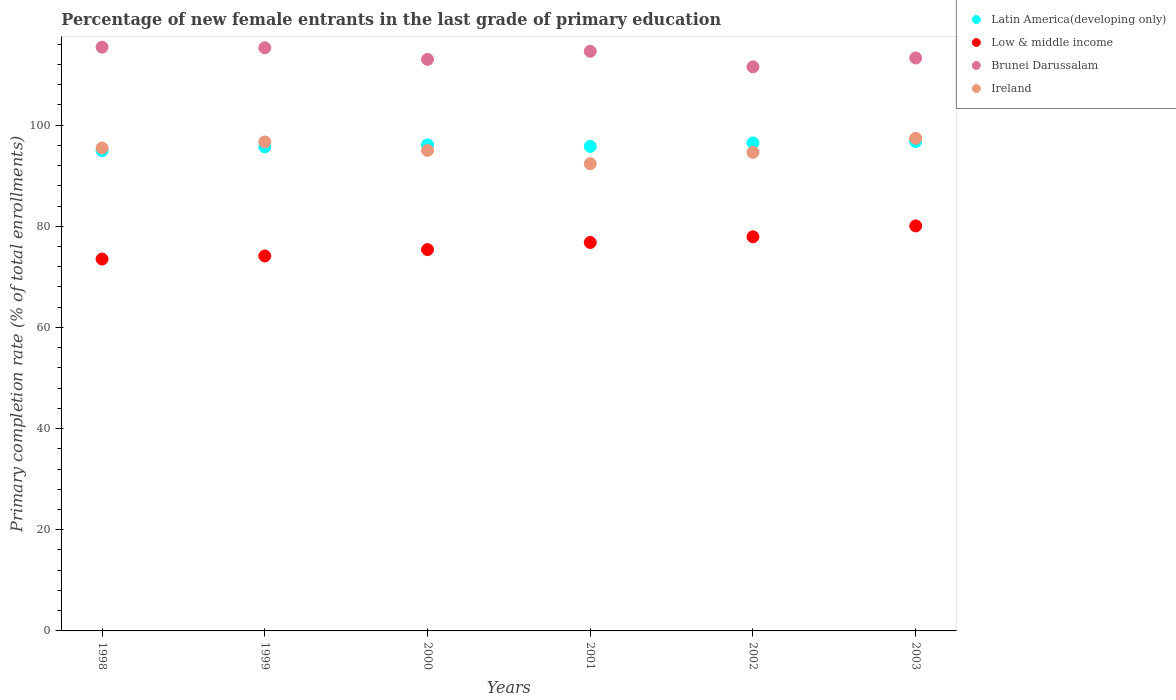How many different coloured dotlines are there?
Give a very brief answer. 4. What is the percentage of new female entrants in Brunei Darussalam in 1999?
Your answer should be compact. 115.28. Across all years, what is the maximum percentage of new female entrants in Ireland?
Provide a short and direct response. 97.38. Across all years, what is the minimum percentage of new female entrants in Low & middle income?
Give a very brief answer. 73.51. In which year was the percentage of new female entrants in Latin America(developing only) maximum?
Give a very brief answer. 2003. What is the total percentage of new female entrants in Low & middle income in the graph?
Give a very brief answer. 457.8. What is the difference between the percentage of new female entrants in Brunei Darussalam in 1999 and that in 2001?
Provide a succinct answer. 0.69. What is the difference between the percentage of new female entrants in Brunei Darussalam in 2002 and the percentage of new female entrants in Latin America(developing only) in 2000?
Offer a terse response. 15.44. What is the average percentage of new female entrants in Latin America(developing only) per year?
Your answer should be compact. 95.95. In the year 2002, what is the difference between the percentage of new female entrants in Brunei Darussalam and percentage of new female entrants in Latin America(developing only)?
Offer a terse response. 15.05. In how many years, is the percentage of new female entrants in Brunei Darussalam greater than 20 %?
Provide a short and direct response. 6. What is the ratio of the percentage of new female entrants in Brunei Darussalam in 2000 to that in 2003?
Your answer should be compact. 1. What is the difference between the highest and the second highest percentage of new female entrants in Latin America(developing only)?
Ensure brevity in your answer.  0.29. What is the difference between the highest and the lowest percentage of new female entrants in Low & middle income?
Provide a short and direct response. 6.55. Is it the case that in every year, the sum of the percentage of new female entrants in Low & middle income and percentage of new female entrants in Latin America(developing only)  is greater than the sum of percentage of new female entrants in Ireland and percentage of new female entrants in Brunei Darussalam?
Your answer should be very brief. No. Does the percentage of new female entrants in Latin America(developing only) monotonically increase over the years?
Your response must be concise. No. Is the percentage of new female entrants in Low & middle income strictly greater than the percentage of new female entrants in Latin America(developing only) over the years?
Your response must be concise. No. How many dotlines are there?
Give a very brief answer. 4. How many years are there in the graph?
Keep it short and to the point. 6. What is the difference between two consecutive major ticks on the Y-axis?
Provide a succinct answer. 20. Are the values on the major ticks of Y-axis written in scientific E-notation?
Your answer should be very brief. No. Does the graph contain grids?
Ensure brevity in your answer.  No. How are the legend labels stacked?
Keep it short and to the point. Vertical. What is the title of the graph?
Your answer should be compact. Percentage of new female entrants in the last grade of primary education. Does "Sao Tome and Principe" appear as one of the legend labels in the graph?
Make the answer very short. No. What is the label or title of the X-axis?
Your response must be concise. Years. What is the label or title of the Y-axis?
Offer a very short reply. Primary completion rate (% of total enrollments). What is the Primary completion rate (% of total enrollments) in Latin America(developing only) in 1998?
Make the answer very short. 94.95. What is the Primary completion rate (% of total enrollments) in Low & middle income in 1998?
Ensure brevity in your answer.  73.51. What is the Primary completion rate (% of total enrollments) in Brunei Darussalam in 1998?
Keep it short and to the point. 115.4. What is the Primary completion rate (% of total enrollments) of Ireland in 1998?
Provide a short and direct response. 95.48. What is the Primary completion rate (% of total enrollments) of Latin America(developing only) in 1999?
Keep it short and to the point. 95.68. What is the Primary completion rate (% of total enrollments) in Low & middle income in 1999?
Offer a very short reply. 74.12. What is the Primary completion rate (% of total enrollments) in Brunei Darussalam in 1999?
Offer a very short reply. 115.28. What is the Primary completion rate (% of total enrollments) of Ireland in 1999?
Provide a succinct answer. 96.67. What is the Primary completion rate (% of total enrollments) of Latin America(developing only) in 2000?
Keep it short and to the point. 96.08. What is the Primary completion rate (% of total enrollments) of Low & middle income in 2000?
Keep it short and to the point. 75.38. What is the Primary completion rate (% of total enrollments) of Brunei Darussalam in 2000?
Offer a very short reply. 112.98. What is the Primary completion rate (% of total enrollments) in Ireland in 2000?
Make the answer very short. 94.98. What is the Primary completion rate (% of total enrollments) in Latin America(developing only) in 2001?
Offer a terse response. 95.79. What is the Primary completion rate (% of total enrollments) in Low & middle income in 2001?
Give a very brief answer. 76.79. What is the Primary completion rate (% of total enrollments) of Brunei Darussalam in 2001?
Make the answer very short. 114.59. What is the Primary completion rate (% of total enrollments) of Ireland in 2001?
Your answer should be very brief. 92.36. What is the Primary completion rate (% of total enrollments) in Latin America(developing only) in 2002?
Provide a succinct answer. 96.47. What is the Primary completion rate (% of total enrollments) of Low & middle income in 2002?
Make the answer very short. 77.92. What is the Primary completion rate (% of total enrollments) of Brunei Darussalam in 2002?
Ensure brevity in your answer.  111.51. What is the Primary completion rate (% of total enrollments) of Ireland in 2002?
Offer a terse response. 94.61. What is the Primary completion rate (% of total enrollments) of Latin America(developing only) in 2003?
Provide a succinct answer. 96.75. What is the Primary completion rate (% of total enrollments) of Low & middle income in 2003?
Provide a succinct answer. 80.07. What is the Primary completion rate (% of total enrollments) of Brunei Darussalam in 2003?
Keep it short and to the point. 113.27. What is the Primary completion rate (% of total enrollments) of Ireland in 2003?
Provide a short and direct response. 97.38. Across all years, what is the maximum Primary completion rate (% of total enrollments) of Latin America(developing only)?
Keep it short and to the point. 96.75. Across all years, what is the maximum Primary completion rate (% of total enrollments) of Low & middle income?
Provide a succinct answer. 80.07. Across all years, what is the maximum Primary completion rate (% of total enrollments) in Brunei Darussalam?
Make the answer very short. 115.4. Across all years, what is the maximum Primary completion rate (% of total enrollments) of Ireland?
Make the answer very short. 97.38. Across all years, what is the minimum Primary completion rate (% of total enrollments) of Latin America(developing only)?
Give a very brief answer. 94.95. Across all years, what is the minimum Primary completion rate (% of total enrollments) in Low & middle income?
Provide a short and direct response. 73.51. Across all years, what is the minimum Primary completion rate (% of total enrollments) in Brunei Darussalam?
Provide a short and direct response. 111.51. Across all years, what is the minimum Primary completion rate (% of total enrollments) of Ireland?
Your response must be concise. 92.36. What is the total Primary completion rate (% of total enrollments) of Latin America(developing only) in the graph?
Give a very brief answer. 575.71. What is the total Primary completion rate (% of total enrollments) of Low & middle income in the graph?
Your answer should be compact. 457.8. What is the total Primary completion rate (% of total enrollments) of Brunei Darussalam in the graph?
Your answer should be very brief. 683.04. What is the total Primary completion rate (% of total enrollments) of Ireland in the graph?
Provide a succinct answer. 571.48. What is the difference between the Primary completion rate (% of total enrollments) of Latin America(developing only) in 1998 and that in 1999?
Provide a short and direct response. -0.74. What is the difference between the Primary completion rate (% of total enrollments) in Low & middle income in 1998 and that in 1999?
Your answer should be compact. -0.61. What is the difference between the Primary completion rate (% of total enrollments) of Brunei Darussalam in 1998 and that in 1999?
Ensure brevity in your answer.  0.12. What is the difference between the Primary completion rate (% of total enrollments) in Ireland in 1998 and that in 1999?
Ensure brevity in your answer.  -1.19. What is the difference between the Primary completion rate (% of total enrollments) of Latin America(developing only) in 1998 and that in 2000?
Provide a succinct answer. -1.13. What is the difference between the Primary completion rate (% of total enrollments) in Low & middle income in 1998 and that in 2000?
Make the answer very short. -1.87. What is the difference between the Primary completion rate (% of total enrollments) in Brunei Darussalam in 1998 and that in 2000?
Your answer should be compact. 2.42. What is the difference between the Primary completion rate (% of total enrollments) in Ireland in 1998 and that in 2000?
Your answer should be compact. 0.49. What is the difference between the Primary completion rate (% of total enrollments) in Latin America(developing only) in 1998 and that in 2001?
Ensure brevity in your answer.  -0.84. What is the difference between the Primary completion rate (% of total enrollments) of Low & middle income in 1998 and that in 2001?
Your answer should be compact. -3.28. What is the difference between the Primary completion rate (% of total enrollments) in Brunei Darussalam in 1998 and that in 2001?
Provide a succinct answer. 0.81. What is the difference between the Primary completion rate (% of total enrollments) of Ireland in 1998 and that in 2001?
Provide a short and direct response. 3.12. What is the difference between the Primary completion rate (% of total enrollments) in Latin America(developing only) in 1998 and that in 2002?
Offer a very short reply. -1.52. What is the difference between the Primary completion rate (% of total enrollments) in Low & middle income in 1998 and that in 2002?
Your response must be concise. -4.4. What is the difference between the Primary completion rate (% of total enrollments) in Brunei Darussalam in 1998 and that in 2002?
Make the answer very short. 3.89. What is the difference between the Primary completion rate (% of total enrollments) in Ireland in 1998 and that in 2002?
Keep it short and to the point. 0.87. What is the difference between the Primary completion rate (% of total enrollments) in Latin America(developing only) in 1998 and that in 2003?
Ensure brevity in your answer.  -1.81. What is the difference between the Primary completion rate (% of total enrollments) in Low & middle income in 1998 and that in 2003?
Ensure brevity in your answer.  -6.55. What is the difference between the Primary completion rate (% of total enrollments) of Brunei Darussalam in 1998 and that in 2003?
Offer a terse response. 2.13. What is the difference between the Primary completion rate (% of total enrollments) of Ireland in 1998 and that in 2003?
Make the answer very short. -1.9. What is the difference between the Primary completion rate (% of total enrollments) in Latin America(developing only) in 1999 and that in 2000?
Offer a terse response. -0.39. What is the difference between the Primary completion rate (% of total enrollments) of Low & middle income in 1999 and that in 2000?
Ensure brevity in your answer.  -1.26. What is the difference between the Primary completion rate (% of total enrollments) in Brunei Darussalam in 1999 and that in 2000?
Your response must be concise. 2.3. What is the difference between the Primary completion rate (% of total enrollments) in Ireland in 1999 and that in 2000?
Your response must be concise. 1.68. What is the difference between the Primary completion rate (% of total enrollments) in Latin America(developing only) in 1999 and that in 2001?
Provide a succinct answer. -0.1. What is the difference between the Primary completion rate (% of total enrollments) of Low & middle income in 1999 and that in 2001?
Your response must be concise. -2.67. What is the difference between the Primary completion rate (% of total enrollments) of Brunei Darussalam in 1999 and that in 2001?
Your response must be concise. 0.69. What is the difference between the Primary completion rate (% of total enrollments) in Ireland in 1999 and that in 2001?
Keep it short and to the point. 4.31. What is the difference between the Primary completion rate (% of total enrollments) of Latin America(developing only) in 1999 and that in 2002?
Give a very brief answer. -0.78. What is the difference between the Primary completion rate (% of total enrollments) in Low & middle income in 1999 and that in 2002?
Provide a succinct answer. -3.79. What is the difference between the Primary completion rate (% of total enrollments) of Brunei Darussalam in 1999 and that in 2002?
Offer a terse response. 3.77. What is the difference between the Primary completion rate (% of total enrollments) of Ireland in 1999 and that in 2002?
Keep it short and to the point. 2.06. What is the difference between the Primary completion rate (% of total enrollments) of Latin America(developing only) in 1999 and that in 2003?
Your answer should be compact. -1.07. What is the difference between the Primary completion rate (% of total enrollments) in Low & middle income in 1999 and that in 2003?
Your answer should be compact. -5.94. What is the difference between the Primary completion rate (% of total enrollments) of Brunei Darussalam in 1999 and that in 2003?
Your answer should be very brief. 2.01. What is the difference between the Primary completion rate (% of total enrollments) in Ireland in 1999 and that in 2003?
Offer a very short reply. -0.72. What is the difference between the Primary completion rate (% of total enrollments) of Latin America(developing only) in 2000 and that in 2001?
Provide a short and direct response. 0.29. What is the difference between the Primary completion rate (% of total enrollments) in Low & middle income in 2000 and that in 2001?
Offer a very short reply. -1.41. What is the difference between the Primary completion rate (% of total enrollments) of Brunei Darussalam in 2000 and that in 2001?
Your answer should be very brief. -1.61. What is the difference between the Primary completion rate (% of total enrollments) in Ireland in 2000 and that in 2001?
Offer a terse response. 2.63. What is the difference between the Primary completion rate (% of total enrollments) in Latin America(developing only) in 2000 and that in 2002?
Offer a terse response. -0.39. What is the difference between the Primary completion rate (% of total enrollments) in Low & middle income in 2000 and that in 2002?
Keep it short and to the point. -2.53. What is the difference between the Primary completion rate (% of total enrollments) of Brunei Darussalam in 2000 and that in 2002?
Keep it short and to the point. 1.47. What is the difference between the Primary completion rate (% of total enrollments) of Ireland in 2000 and that in 2002?
Offer a terse response. 0.37. What is the difference between the Primary completion rate (% of total enrollments) in Latin America(developing only) in 2000 and that in 2003?
Provide a short and direct response. -0.68. What is the difference between the Primary completion rate (% of total enrollments) in Low & middle income in 2000 and that in 2003?
Give a very brief answer. -4.68. What is the difference between the Primary completion rate (% of total enrollments) in Brunei Darussalam in 2000 and that in 2003?
Give a very brief answer. -0.28. What is the difference between the Primary completion rate (% of total enrollments) in Ireland in 2000 and that in 2003?
Make the answer very short. -2.4. What is the difference between the Primary completion rate (% of total enrollments) of Latin America(developing only) in 2001 and that in 2002?
Offer a very short reply. -0.68. What is the difference between the Primary completion rate (% of total enrollments) in Low & middle income in 2001 and that in 2002?
Your answer should be very brief. -1.12. What is the difference between the Primary completion rate (% of total enrollments) in Brunei Darussalam in 2001 and that in 2002?
Provide a short and direct response. 3.08. What is the difference between the Primary completion rate (% of total enrollments) in Ireland in 2001 and that in 2002?
Ensure brevity in your answer.  -2.25. What is the difference between the Primary completion rate (% of total enrollments) of Latin America(developing only) in 2001 and that in 2003?
Offer a very short reply. -0.96. What is the difference between the Primary completion rate (% of total enrollments) in Low & middle income in 2001 and that in 2003?
Offer a terse response. -3.27. What is the difference between the Primary completion rate (% of total enrollments) of Brunei Darussalam in 2001 and that in 2003?
Your answer should be compact. 1.32. What is the difference between the Primary completion rate (% of total enrollments) in Ireland in 2001 and that in 2003?
Your response must be concise. -5.03. What is the difference between the Primary completion rate (% of total enrollments) in Latin America(developing only) in 2002 and that in 2003?
Offer a very short reply. -0.29. What is the difference between the Primary completion rate (% of total enrollments) in Low & middle income in 2002 and that in 2003?
Your answer should be very brief. -2.15. What is the difference between the Primary completion rate (% of total enrollments) in Brunei Darussalam in 2002 and that in 2003?
Your answer should be very brief. -1.76. What is the difference between the Primary completion rate (% of total enrollments) of Ireland in 2002 and that in 2003?
Ensure brevity in your answer.  -2.77. What is the difference between the Primary completion rate (% of total enrollments) in Latin America(developing only) in 1998 and the Primary completion rate (% of total enrollments) in Low & middle income in 1999?
Provide a succinct answer. 20.82. What is the difference between the Primary completion rate (% of total enrollments) in Latin America(developing only) in 1998 and the Primary completion rate (% of total enrollments) in Brunei Darussalam in 1999?
Make the answer very short. -20.33. What is the difference between the Primary completion rate (% of total enrollments) of Latin America(developing only) in 1998 and the Primary completion rate (% of total enrollments) of Ireland in 1999?
Keep it short and to the point. -1.72. What is the difference between the Primary completion rate (% of total enrollments) of Low & middle income in 1998 and the Primary completion rate (% of total enrollments) of Brunei Darussalam in 1999?
Offer a very short reply. -41.77. What is the difference between the Primary completion rate (% of total enrollments) of Low & middle income in 1998 and the Primary completion rate (% of total enrollments) of Ireland in 1999?
Offer a terse response. -23.16. What is the difference between the Primary completion rate (% of total enrollments) of Brunei Darussalam in 1998 and the Primary completion rate (% of total enrollments) of Ireland in 1999?
Make the answer very short. 18.73. What is the difference between the Primary completion rate (% of total enrollments) of Latin America(developing only) in 1998 and the Primary completion rate (% of total enrollments) of Low & middle income in 2000?
Your answer should be very brief. 19.56. What is the difference between the Primary completion rate (% of total enrollments) in Latin America(developing only) in 1998 and the Primary completion rate (% of total enrollments) in Brunei Darussalam in 2000?
Your response must be concise. -18.04. What is the difference between the Primary completion rate (% of total enrollments) of Latin America(developing only) in 1998 and the Primary completion rate (% of total enrollments) of Ireland in 2000?
Your response must be concise. -0.04. What is the difference between the Primary completion rate (% of total enrollments) of Low & middle income in 1998 and the Primary completion rate (% of total enrollments) of Brunei Darussalam in 2000?
Ensure brevity in your answer.  -39.47. What is the difference between the Primary completion rate (% of total enrollments) in Low & middle income in 1998 and the Primary completion rate (% of total enrollments) in Ireland in 2000?
Make the answer very short. -21.47. What is the difference between the Primary completion rate (% of total enrollments) of Brunei Darussalam in 1998 and the Primary completion rate (% of total enrollments) of Ireland in 2000?
Your response must be concise. 20.42. What is the difference between the Primary completion rate (% of total enrollments) in Latin America(developing only) in 1998 and the Primary completion rate (% of total enrollments) in Low & middle income in 2001?
Give a very brief answer. 18.15. What is the difference between the Primary completion rate (% of total enrollments) in Latin America(developing only) in 1998 and the Primary completion rate (% of total enrollments) in Brunei Darussalam in 2001?
Ensure brevity in your answer.  -19.64. What is the difference between the Primary completion rate (% of total enrollments) in Latin America(developing only) in 1998 and the Primary completion rate (% of total enrollments) in Ireland in 2001?
Give a very brief answer. 2.59. What is the difference between the Primary completion rate (% of total enrollments) of Low & middle income in 1998 and the Primary completion rate (% of total enrollments) of Brunei Darussalam in 2001?
Your response must be concise. -41.08. What is the difference between the Primary completion rate (% of total enrollments) of Low & middle income in 1998 and the Primary completion rate (% of total enrollments) of Ireland in 2001?
Offer a terse response. -18.84. What is the difference between the Primary completion rate (% of total enrollments) of Brunei Darussalam in 1998 and the Primary completion rate (% of total enrollments) of Ireland in 2001?
Provide a succinct answer. 23.05. What is the difference between the Primary completion rate (% of total enrollments) of Latin America(developing only) in 1998 and the Primary completion rate (% of total enrollments) of Low & middle income in 2002?
Keep it short and to the point. 17.03. What is the difference between the Primary completion rate (% of total enrollments) in Latin America(developing only) in 1998 and the Primary completion rate (% of total enrollments) in Brunei Darussalam in 2002?
Provide a succinct answer. -16.57. What is the difference between the Primary completion rate (% of total enrollments) of Latin America(developing only) in 1998 and the Primary completion rate (% of total enrollments) of Ireland in 2002?
Offer a terse response. 0.34. What is the difference between the Primary completion rate (% of total enrollments) of Low & middle income in 1998 and the Primary completion rate (% of total enrollments) of Brunei Darussalam in 2002?
Keep it short and to the point. -38. What is the difference between the Primary completion rate (% of total enrollments) of Low & middle income in 1998 and the Primary completion rate (% of total enrollments) of Ireland in 2002?
Give a very brief answer. -21.1. What is the difference between the Primary completion rate (% of total enrollments) in Brunei Darussalam in 1998 and the Primary completion rate (% of total enrollments) in Ireland in 2002?
Ensure brevity in your answer.  20.79. What is the difference between the Primary completion rate (% of total enrollments) of Latin America(developing only) in 1998 and the Primary completion rate (% of total enrollments) of Low & middle income in 2003?
Your response must be concise. 14.88. What is the difference between the Primary completion rate (% of total enrollments) in Latin America(developing only) in 1998 and the Primary completion rate (% of total enrollments) in Brunei Darussalam in 2003?
Provide a succinct answer. -18.32. What is the difference between the Primary completion rate (% of total enrollments) in Latin America(developing only) in 1998 and the Primary completion rate (% of total enrollments) in Ireland in 2003?
Make the answer very short. -2.44. What is the difference between the Primary completion rate (% of total enrollments) in Low & middle income in 1998 and the Primary completion rate (% of total enrollments) in Brunei Darussalam in 2003?
Your answer should be compact. -39.76. What is the difference between the Primary completion rate (% of total enrollments) of Low & middle income in 1998 and the Primary completion rate (% of total enrollments) of Ireland in 2003?
Your response must be concise. -23.87. What is the difference between the Primary completion rate (% of total enrollments) of Brunei Darussalam in 1998 and the Primary completion rate (% of total enrollments) of Ireland in 2003?
Offer a terse response. 18.02. What is the difference between the Primary completion rate (% of total enrollments) of Latin America(developing only) in 1999 and the Primary completion rate (% of total enrollments) of Low & middle income in 2000?
Make the answer very short. 20.3. What is the difference between the Primary completion rate (% of total enrollments) of Latin America(developing only) in 1999 and the Primary completion rate (% of total enrollments) of Brunei Darussalam in 2000?
Your response must be concise. -17.3. What is the difference between the Primary completion rate (% of total enrollments) in Latin America(developing only) in 1999 and the Primary completion rate (% of total enrollments) in Ireland in 2000?
Offer a terse response. 0.7. What is the difference between the Primary completion rate (% of total enrollments) of Low & middle income in 1999 and the Primary completion rate (% of total enrollments) of Brunei Darussalam in 2000?
Provide a short and direct response. -38.86. What is the difference between the Primary completion rate (% of total enrollments) in Low & middle income in 1999 and the Primary completion rate (% of total enrollments) in Ireland in 2000?
Offer a terse response. -20.86. What is the difference between the Primary completion rate (% of total enrollments) in Brunei Darussalam in 1999 and the Primary completion rate (% of total enrollments) in Ireland in 2000?
Keep it short and to the point. 20.3. What is the difference between the Primary completion rate (% of total enrollments) of Latin America(developing only) in 1999 and the Primary completion rate (% of total enrollments) of Low & middle income in 2001?
Give a very brief answer. 18.89. What is the difference between the Primary completion rate (% of total enrollments) of Latin America(developing only) in 1999 and the Primary completion rate (% of total enrollments) of Brunei Darussalam in 2001?
Provide a short and direct response. -18.91. What is the difference between the Primary completion rate (% of total enrollments) of Latin America(developing only) in 1999 and the Primary completion rate (% of total enrollments) of Ireland in 2001?
Your answer should be compact. 3.33. What is the difference between the Primary completion rate (% of total enrollments) in Low & middle income in 1999 and the Primary completion rate (% of total enrollments) in Brunei Darussalam in 2001?
Provide a succinct answer. -40.47. What is the difference between the Primary completion rate (% of total enrollments) of Low & middle income in 1999 and the Primary completion rate (% of total enrollments) of Ireland in 2001?
Your answer should be very brief. -18.23. What is the difference between the Primary completion rate (% of total enrollments) in Brunei Darussalam in 1999 and the Primary completion rate (% of total enrollments) in Ireland in 2001?
Keep it short and to the point. 22.92. What is the difference between the Primary completion rate (% of total enrollments) in Latin America(developing only) in 1999 and the Primary completion rate (% of total enrollments) in Low & middle income in 2002?
Your answer should be very brief. 17.77. What is the difference between the Primary completion rate (% of total enrollments) in Latin America(developing only) in 1999 and the Primary completion rate (% of total enrollments) in Brunei Darussalam in 2002?
Provide a succinct answer. -15.83. What is the difference between the Primary completion rate (% of total enrollments) in Latin America(developing only) in 1999 and the Primary completion rate (% of total enrollments) in Ireland in 2002?
Give a very brief answer. 1.07. What is the difference between the Primary completion rate (% of total enrollments) in Low & middle income in 1999 and the Primary completion rate (% of total enrollments) in Brunei Darussalam in 2002?
Your answer should be compact. -37.39. What is the difference between the Primary completion rate (% of total enrollments) of Low & middle income in 1999 and the Primary completion rate (% of total enrollments) of Ireland in 2002?
Ensure brevity in your answer.  -20.49. What is the difference between the Primary completion rate (% of total enrollments) in Brunei Darussalam in 1999 and the Primary completion rate (% of total enrollments) in Ireland in 2002?
Provide a succinct answer. 20.67. What is the difference between the Primary completion rate (% of total enrollments) of Latin America(developing only) in 1999 and the Primary completion rate (% of total enrollments) of Low & middle income in 2003?
Your answer should be compact. 15.62. What is the difference between the Primary completion rate (% of total enrollments) of Latin America(developing only) in 1999 and the Primary completion rate (% of total enrollments) of Brunei Darussalam in 2003?
Your response must be concise. -17.58. What is the difference between the Primary completion rate (% of total enrollments) in Latin America(developing only) in 1999 and the Primary completion rate (% of total enrollments) in Ireland in 2003?
Make the answer very short. -1.7. What is the difference between the Primary completion rate (% of total enrollments) in Low & middle income in 1999 and the Primary completion rate (% of total enrollments) in Brunei Darussalam in 2003?
Provide a short and direct response. -39.14. What is the difference between the Primary completion rate (% of total enrollments) in Low & middle income in 1999 and the Primary completion rate (% of total enrollments) in Ireland in 2003?
Offer a terse response. -23.26. What is the difference between the Primary completion rate (% of total enrollments) in Brunei Darussalam in 1999 and the Primary completion rate (% of total enrollments) in Ireland in 2003?
Give a very brief answer. 17.9. What is the difference between the Primary completion rate (% of total enrollments) of Latin America(developing only) in 2000 and the Primary completion rate (% of total enrollments) of Low & middle income in 2001?
Make the answer very short. 19.28. What is the difference between the Primary completion rate (% of total enrollments) in Latin America(developing only) in 2000 and the Primary completion rate (% of total enrollments) in Brunei Darussalam in 2001?
Give a very brief answer. -18.51. What is the difference between the Primary completion rate (% of total enrollments) in Latin America(developing only) in 2000 and the Primary completion rate (% of total enrollments) in Ireland in 2001?
Your answer should be compact. 3.72. What is the difference between the Primary completion rate (% of total enrollments) of Low & middle income in 2000 and the Primary completion rate (% of total enrollments) of Brunei Darussalam in 2001?
Offer a very short reply. -39.21. What is the difference between the Primary completion rate (% of total enrollments) of Low & middle income in 2000 and the Primary completion rate (% of total enrollments) of Ireland in 2001?
Give a very brief answer. -16.97. What is the difference between the Primary completion rate (% of total enrollments) of Brunei Darussalam in 2000 and the Primary completion rate (% of total enrollments) of Ireland in 2001?
Ensure brevity in your answer.  20.63. What is the difference between the Primary completion rate (% of total enrollments) in Latin America(developing only) in 2000 and the Primary completion rate (% of total enrollments) in Low & middle income in 2002?
Keep it short and to the point. 18.16. What is the difference between the Primary completion rate (% of total enrollments) of Latin America(developing only) in 2000 and the Primary completion rate (% of total enrollments) of Brunei Darussalam in 2002?
Your answer should be compact. -15.44. What is the difference between the Primary completion rate (% of total enrollments) of Latin America(developing only) in 2000 and the Primary completion rate (% of total enrollments) of Ireland in 2002?
Ensure brevity in your answer.  1.46. What is the difference between the Primary completion rate (% of total enrollments) of Low & middle income in 2000 and the Primary completion rate (% of total enrollments) of Brunei Darussalam in 2002?
Ensure brevity in your answer.  -36.13. What is the difference between the Primary completion rate (% of total enrollments) in Low & middle income in 2000 and the Primary completion rate (% of total enrollments) in Ireland in 2002?
Your response must be concise. -19.23. What is the difference between the Primary completion rate (% of total enrollments) of Brunei Darussalam in 2000 and the Primary completion rate (% of total enrollments) of Ireland in 2002?
Keep it short and to the point. 18.37. What is the difference between the Primary completion rate (% of total enrollments) of Latin America(developing only) in 2000 and the Primary completion rate (% of total enrollments) of Low & middle income in 2003?
Give a very brief answer. 16.01. What is the difference between the Primary completion rate (% of total enrollments) of Latin America(developing only) in 2000 and the Primary completion rate (% of total enrollments) of Brunei Darussalam in 2003?
Offer a very short reply. -17.19. What is the difference between the Primary completion rate (% of total enrollments) in Latin America(developing only) in 2000 and the Primary completion rate (% of total enrollments) in Ireland in 2003?
Offer a terse response. -1.31. What is the difference between the Primary completion rate (% of total enrollments) of Low & middle income in 2000 and the Primary completion rate (% of total enrollments) of Brunei Darussalam in 2003?
Provide a short and direct response. -37.89. What is the difference between the Primary completion rate (% of total enrollments) in Low & middle income in 2000 and the Primary completion rate (% of total enrollments) in Ireland in 2003?
Make the answer very short. -22. What is the difference between the Primary completion rate (% of total enrollments) in Brunei Darussalam in 2000 and the Primary completion rate (% of total enrollments) in Ireland in 2003?
Your answer should be very brief. 15.6. What is the difference between the Primary completion rate (% of total enrollments) in Latin America(developing only) in 2001 and the Primary completion rate (% of total enrollments) in Low & middle income in 2002?
Ensure brevity in your answer.  17.87. What is the difference between the Primary completion rate (% of total enrollments) of Latin America(developing only) in 2001 and the Primary completion rate (% of total enrollments) of Brunei Darussalam in 2002?
Your answer should be compact. -15.72. What is the difference between the Primary completion rate (% of total enrollments) of Latin America(developing only) in 2001 and the Primary completion rate (% of total enrollments) of Ireland in 2002?
Your response must be concise. 1.18. What is the difference between the Primary completion rate (% of total enrollments) of Low & middle income in 2001 and the Primary completion rate (% of total enrollments) of Brunei Darussalam in 2002?
Your answer should be very brief. -34.72. What is the difference between the Primary completion rate (% of total enrollments) of Low & middle income in 2001 and the Primary completion rate (% of total enrollments) of Ireland in 2002?
Provide a short and direct response. -17.82. What is the difference between the Primary completion rate (% of total enrollments) of Brunei Darussalam in 2001 and the Primary completion rate (% of total enrollments) of Ireland in 2002?
Your answer should be very brief. 19.98. What is the difference between the Primary completion rate (% of total enrollments) of Latin America(developing only) in 2001 and the Primary completion rate (% of total enrollments) of Low & middle income in 2003?
Your answer should be very brief. 15.72. What is the difference between the Primary completion rate (% of total enrollments) of Latin America(developing only) in 2001 and the Primary completion rate (% of total enrollments) of Brunei Darussalam in 2003?
Give a very brief answer. -17.48. What is the difference between the Primary completion rate (% of total enrollments) in Latin America(developing only) in 2001 and the Primary completion rate (% of total enrollments) in Ireland in 2003?
Your answer should be very brief. -1.59. What is the difference between the Primary completion rate (% of total enrollments) in Low & middle income in 2001 and the Primary completion rate (% of total enrollments) in Brunei Darussalam in 2003?
Your answer should be very brief. -36.48. What is the difference between the Primary completion rate (% of total enrollments) in Low & middle income in 2001 and the Primary completion rate (% of total enrollments) in Ireland in 2003?
Ensure brevity in your answer.  -20.59. What is the difference between the Primary completion rate (% of total enrollments) of Brunei Darussalam in 2001 and the Primary completion rate (% of total enrollments) of Ireland in 2003?
Your answer should be compact. 17.21. What is the difference between the Primary completion rate (% of total enrollments) in Latin America(developing only) in 2002 and the Primary completion rate (% of total enrollments) in Low & middle income in 2003?
Offer a terse response. 16.4. What is the difference between the Primary completion rate (% of total enrollments) in Latin America(developing only) in 2002 and the Primary completion rate (% of total enrollments) in Brunei Darussalam in 2003?
Keep it short and to the point. -16.8. What is the difference between the Primary completion rate (% of total enrollments) of Latin America(developing only) in 2002 and the Primary completion rate (% of total enrollments) of Ireland in 2003?
Provide a succinct answer. -0.92. What is the difference between the Primary completion rate (% of total enrollments) in Low & middle income in 2002 and the Primary completion rate (% of total enrollments) in Brunei Darussalam in 2003?
Give a very brief answer. -35.35. What is the difference between the Primary completion rate (% of total enrollments) of Low & middle income in 2002 and the Primary completion rate (% of total enrollments) of Ireland in 2003?
Offer a very short reply. -19.47. What is the difference between the Primary completion rate (% of total enrollments) of Brunei Darussalam in 2002 and the Primary completion rate (% of total enrollments) of Ireland in 2003?
Make the answer very short. 14.13. What is the average Primary completion rate (% of total enrollments) of Latin America(developing only) per year?
Your answer should be compact. 95.95. What is the average Primary completion rate (% of total enrollments) in Low & middle income per year?
Your answer should be very brief. 76.3. What is the average Primary completion rate (% of total enrollments) of Brunei Darussalam per year?
Provide a succinct answer. 113.84. What is the average Primary completion rate (% of total enrollments) in Ireland per year?
Your response must be concise. 95.25. In the year 1998, what is the difference between the Primary completion rate (% of total enrollments) of Latin America(developing only) and Primary completion rate (% of total enrollments) of Low & middle income?
Provide a short and direct response. 21.43. In the year 1998, what is the difference between the Primary completion rate (% of total enrollments) in Latin America(developing only) and Primary completion rate (% of total enrollments) in Brunei Darussalam?
Ensure brevity in your answer.  -20.46. In the year 1998, what is the difference between the Primary completion rate (% of total enrollments) of Latin America(developing only) and Primary completion rate (% of total enrollments) of Ireland?
Ensure brevity in your answer.  -0.53. In the year 1998, what is the difference between the Primary completion rate (% of total enrollments) of Low & middle income and Primary completion rate (% of total enrollments) of Brunei Darussalam?
Offer a terse response. -41.89. In the year 1998, what is the difference between the Primary completion rate (% of total enrollments) in Low & middle income and Primary completion rate (% of total enrollments) in Ireland?
Make the answer very short. -21.97. In the year 1998, what is the difference between the Primary completion rate (% of total enrollments) of Brunei Darussalam and Primary completion rate (% of total enrollments) of Ireland?
Your answer should be very brief. 19.92. In the year 1999, what is the difference between the Primary completion rate (% of total enrollments) in Latin America(developing only) and Primary completion rate (% of total enrollments) in Low & middle income?
Offer a terse response. 21.56. In the year 1999, what is the difference between the Primary completion rate (% of total enrollments) of Latin America(developing only) and Primary completion rate (% of total enrollments) of Brunei Darussalam?
Your answer should be very brief. -19.6. In the year 1999, what is the difference between the Primary completion rate (% of total enrollments) in Latin America(developing only) and Primary completion rate (% of total enrollments) in Ireland?
Offer a terse response. -0.98. In the year 1999, what is the difference between the Primary completion rate (% of total enrollments) of Low & middle income and Primary completion rate (% of total enrollments) of Brunei Darussalam?
Offer a very short reply. -41.16. In the year 1999, what is the difference between the Primary completion rate (% of total enrollments) in Low & middle income and Primary completion rate (% of total enrollments) in Ireland?
Your answer should be very brief. -22.54. In the year 1999, what is the difference between the Primary completion rate (% of total enrollments) of Brunei Darussalam and Primary completion rate (% of total enrollments) of Ireland?
Make the answer very short. 18.61. In the year 2000, what is the difference between the Primary completion rate (% of total enrollments) in Latin America(developing only) and Primary completion rate (% of total enrollments) in Low & middle income?
Provide a short and direct response. 20.69. In the year 2000, what is the difference between the Primary completion rate (% of total enrollments) of Latin America(developing only) and Primary completion rate (% of total enrollments) of Brunei Darussalam?
Give a very brief answer. -16.91. In the year 2000, what is the difference between the Primary completion rate (% of total enrollments) of Latin America(developing only) and Primary completion rate (% of total enrollments) of Ireland?
Your answer should be compact. 1.09. In the year 2000, what is the difference between the Primary completion rate (% of total enrollments) of Low & middle income and Primary completion rate (% of total enrollments) of Brunei Darussalam?
Offer a terse response. -37.6. In the year 2000, what is the difference between the Primary completion rate (% of total enrollments) in Low & middle income and Primary completion rate (% of total enrollments) in Ireland?
Give a very brief answer. -19.6. In the year 2000, what is the difference between the Primary completion rate (% of total enrollments) of Brunei Darussalam and Primary completion rate (% of total enrollments) of Ireland?
Give a very brief answer. 18. In the year 2001, what is the difference between the Primary completion rate (% of total enrollments) in Latin America(developing only) and Primary completion rate (% of total enrollments) in Low & middle income?
Your response must be concise. 19. In the year 2001, what is the difference between the Primary completion rate (% of total enrollments) in Latin America(developing only) and Primary completion rate (% of total enrollments) in Brunei Darussalam?
Your answer should be compact. -18.8. In the year 2001, what is the difference between the Primary completion rate (% of total enrollments) of Latin America(developing only) and Primary completion rate (% of total enrollments) of Ireland?
Keep it short and to the point. 3.43. In the year 2001, what is the difference between the Primary completion rate (% of total enrollments) in Low & middle income and Primary completion rate (% of total enrollments) in Brunei Darussalam?
Your answer should be compact. -37.8. In the year 2001, what is the difference between the Primary completion rate (% of total enrollments) of Low & middle income and Primary completion rate (% of total enrollments) of Ireland?
Your answer should be very brief. -15.56. In the year 2001, what is the difference between the Primary completion rate (% of total enrollments) of Brunei Darussalam and Primary completion rate (% of total enrollments) of Ireland?
Offer a very short reply. 22.23. In the year 2002, what is the difference between the Primary completion rate (% of total enrollments) in Latin America(developing only) and Primary completion rate (% of total enrollments) in Low & middle income?
Offer a very short reply. 18.55. In the year 2002, what is the difference between the Primary completion rate (% of total enrollments) of Latin America(developing only) and Primary completion rate (% of total enrollments) of Brunei Darussalam?
Offer a terse response. -15.05. In the year 2002, what is the difference between the Primary completion rate (% of total enrollments) of Latin America(developing only) and Primary completion rate (% of total enrollments) of Ireland?
Your answer should be compact. 1.85. In the year 2002, what is the difference between the Primary completion rate (% of total enrollments) of Low & middle income and Primary completion rate (% of total enrollments) of Brunei Darussalam?
Provide a short and direct response. -33.6. In the year 2002, what is the difference between the Primary completion rate (% of total enrollments) in Low & middle income and Primary completion rate (% of total enrollments) in Ireland?
Provide a succinct answer. -16.69. In the year 2002, what is the difference between the Primary completion rate (% of total enrollments) in Brunei Darussalam and Primary completion rate (% of total enrollments) in Ireland?
Give a very brief answer. 16.9. In the year 2003, what is the difference between the Primary completion rate (% of total enrollments) in Latin America(developing only) and Primary completion rate (% of total enrollments) in Low & middle income?
Provide a short and direct response. 16.68. In the year 2003, what is the difference between the Primary completion rate (% of total enrollments) of Latin America(developing only) and Primary completion rate (% of total enrollments) of Brunei Darussalam?
Keep it short and to the point. -16.52. In the year 2003, what is the difference between the Primary completion rate (% of total enrollments) of Latin America(developing only) and Primary completion rate (% of total enrollments) of Ireland?
Your answer should be very brief. -0.63. In the year 2003, what is the difference between the Primary completion rate (% of total enrollments) in Low & middle income and Primary completion rate (% of total enrollments) in Brunei Darussalam?
Give a very brief answer. -33.2. In the year 2003, what is the difference between the Primary completion rate (% of total enrollments) in Low & middle income and Primary completion rate (% of total enrollments) in Ireland?
Your answer should be compact. -17.32. In the year 2003, what is the difference between the Primary completion rate (% of total enrollments) of Brunei Darussalam and Primary completion rate (% of total enrollments) of Ireland?
Make the answer very short. 15.89. What is the ratio of the Primary completion rate (% of total enrollments) of Low & middle income in 1998 to that in 1999?
Offer a terse response. 0.99. What is the ratio of the Primary completion rate (% of total enrollments) in Brunei Darussalam in 1998 to that in 1999?
Provide a succinct answer. 1. What is the ratio of the Primary completion rate (% of total enrollments) in Low & middle income in 1998 to that in 2000?
Provide a short and direct response. 0.98. What is the ratio of the Primary completion rate (% of total enrollments) in Brunei Darussalam in 1998 to that in 2000?
Offer a very short reply. 1.02. What is the ratio of the Primary completion rate (% of total enrollments) of Ireland in 1998 to that in 2000?
Your response must be concise. 1.01. What is the ratio of the Primary completion rate (% of total enrollments) in Low & middle income in 1998 to that in 2001?
Provide a short and direct response. 0.96. What is the ratio of the Primary completion rate (% of total enrollments) of Brunei Darussalam in 1998 to that in 2001?
Ensure brevity in your answer.  1.01. What is the ratio of the Primary completion rate (% of total enrollments) in Ireland in 1998 to that in 2001?
Offer a terse response. 1.03. What is the ratio of the Primary completion rate (% of total enrollments) of Latin America(developing only) in 1998 to that in 2002?
Your response must be concise. 0.98. What is the ratio of the Primary completion rate (% of total enrollments) of Low & middle income in 1998 to that in 2002?
Your response must be concise. 0.94. What is the ratio of the Primary completion rate (% of total enrollments) in Brunei Darussalam in 1998 to that in 2002?
Give a very brief answer. 1.03. What is the ratio of the Primary completion rate (% of total enrollments) of Ireland in 1998 to that in 2002?
Your response must be concise. 1.01. What is the ratio of the Primary completion rate (% of total enrollments) of Latin America(developing only) in 1998 to that in 2003?
Provide a succinct answer. 0.98. What is the ratio of the Primary completion rate (% of total enrollments) in Low & middle income in 1998 to that in 2003?
Your response must be concise. 0.92. What is the ratio of the Primary completion rate (% of total enrollments) in Brunei Darussalam in 1998 to that in 2003?
Your answer should be very brief. 1.02. What is the ratio of the Primary completion rate (% of total enrollments) in Ireland in 1998 to that in 2003?
Give a very brief answer. 0.98. What is the ratio of the Primary completion rate (% of total enrollments) in Latin America(developing only) in 1999 to that in 2000?
Provide a short and direct response. 1. What is the ratio of the Primary completion rate (% of total enrollments) of Low & middle income in 1999 to that in 2000?
Give a very brief answer. 0.98. What is the ratio of the Primary completion rate (% of total enrollments) of Brunei Darussalam in 1999 to that in 2000?
Provide a short and direct response. 1.02. What is the ratio of the Primary completion rate (% of total enrollments) in Ireland in 1999 to that in 2000?
Your answer should be compact. 1.02. What is the ratio of the Primary completion rate (% of total enrollments) of Low & middle income in 1999 to that in 2001?
Provide a succinct answer. 0.97. What is the ratio of the Primary completion rate (% of total enrollments) of Ireland in 1999 to that in 2001?
Your answer should be compact. 1.05. What is the ratio of the Primary completion rate (% of total enrollments) in Latin America(developing only) in 1999 to that in 2002?
Your answer should be compact. 0.99. What is the ratio of the Primary completion rate (% of total enrollments) in Low & middle income in 1999 to that in 2002?
Keep it short and to the point. 0.95. What is the ratio of the Primary completion rate (% of total enrollments) in Brunei Darussalam in 1999 to that in 2002?
Provide a short and direct response. 1.03. What is the ratio of the Primary completion rate (% of total enrollments) in Ireland in 1999 to that in 2002?
Provide a short and direct response. 1.02. What is the ratio of the Primary completion rate (% of total enrollments) of Latin America(developing only) in 1999 to that in 2003?
Offer a very short reply. 0.99. What is the ratio of the Primary completion rate (% of total enrollments) of Low & middle income in 1999 to that in 2003?
Make the answer very short. 0.93. What is the ratio of the Primary completion rate (% of total enrollments) of Brunei Darussalam in 1999 to that in 2003?
Give a very brief answer. 1.02. What is the ratio of the Primary completion rate (% of total enrollments) of Low & middle income in 2000 to that in 2001?
Offer a very short reply. 0.98. What is the ratio of the Primary completion rate (% of total enrollments) of Ireland in 2000 to that in 2001?
Your answer should be compact. 1.03. What is the ratio of the Primary completion rate (% of total enrollments) in Latin America(developing only) in 2000 to that in 2002?
Your response must be concise. 1. What is the ratio of the Primary completion rate (% of total enrollments) in Low & middle income in 2000 to that in 2002?
Ensure brevity in your answer.  0.97. What is the ratio of the Primary completion rate (% of total enrollments) of Brunei Darussalam in 2000 to that in 2002?
Give a very brief answer. 1.01. What is the ratio of the Primary completion rate (% of total enrollments) in Low & middle income in 2000 to that in 2003?
Your response must be concise. 0.94. What is the ratio of the Primary completion rate (% of total enrollments) of Ireland in 2000 to that in 2003?
Your answer should be compact. 0.98. What is the ratio of the Primary completion rate (% of total enrollments) in Latin America(developing only) in 2001 to that in 2002?
Keep it short and to the point. 0.99. What is the ratio of the Primary completion rate (% of total enrollments) in Low & middle income in 2001 to that in 2002?
Your response must be concise. 0.99. What is the ratio of the Primary completion rate (% of total enrollments) in Brunei Darussalam in 2001 to that in 2002?
Keep it short and to the point. 1.03. What is the ratio of the Primary completion rate (% of total enrollments) in Ireland in 2001 to that in 2002?
Make the answer very short. 0.98. What is the ratio of the Primary completion rate (% of total enrollments) in Latin America(developing only) in 2001 to that in 2003?
Keep it short and to the point. 0.99. What is the ratio of the Primary completion rate (% of total enrollments) of Low & middle income in 2001 to that in 2003?
Keep it short and to the point. 0.96. What is the ratio of the Primary completion rate (% of total enrollments) of Brunei Darussalam in 2001 to that in 2003?
Offer a terse response. 1.01. What is the ratio of the Primary completion rate (% of total enrollments) of Ireland in 2001 to that in 2003?
Keep it short and to the point. 0.95. What is the ratio of the Primary completion rate (% of total enrollments) in Latin America(developing only) in 2002 to that in 2003?
Keep it short and to the point. 1. What is the ratio of the Primary completion rate (% of total enrollments) of Low & middle income in 2002 to that in 2003?
Your response must be concise. 0.97. What is the ratio of the Primary completion rate (% of total enrollments) of Brunei Darussalam in 2002 to that in 2003?
Your response must be concise. 0.98. What is the ratio of the Primary completion rate (% of total enrollments) of Ireland in 2002 to that in 2003?
Ensure brevity in your answer.  0.97. What is the difference between the highest and the second highest Primary completion rate (% of total enrollments) in Latin America(developing only)?
Make the answer very short. 0.29. What is the difference between the highest and the second highest Primary completion rate (% of total enrollments) in Low & middle income?
Your answer should be very brief. 2.15. What is the difference between the highest and the second highest Primary completion rate (% of total enrollments) of Brunei Darussalam?
Keep it short and to the point. 0.12. What is the difference between the highest and the second highest Primary completion rate (% of total enrollments) of Ireland?
Provide a short and direct response. 0.72. What is the difference between the highest and the lowest Primary completion rate (% of total enrollments) in Latin America(developing only)?
Provide a short and direct response. 1.81. What is the difference between the highest and the lowest Primary completion rate (% of total enrollments) in Low & middle income?
Make the answer very short. 6.55. What is the difference between the highest and the lowest Primary completion rate (% of total enrollments) in Brunei Darussalam?
Make the answer very short. 3.89. What is the difference between the highest and the lowest Primary completion rate (% of total enrollments) of Ireland?
Your response must be concise. 5.03. 